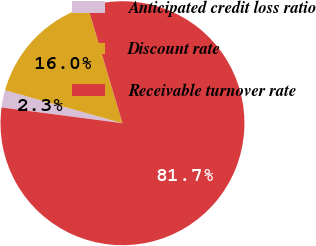Convert chart. <chart><loc_0><loc_0><loc_500><loc_500><pie_chart><fcel>Anticipated credit loss ratio<fcel>Discount rate<fcel>Receivable turnover rate<nl><fcel>2.29%<fcel>16.03%<fcel>81.68%<nl></chart> 